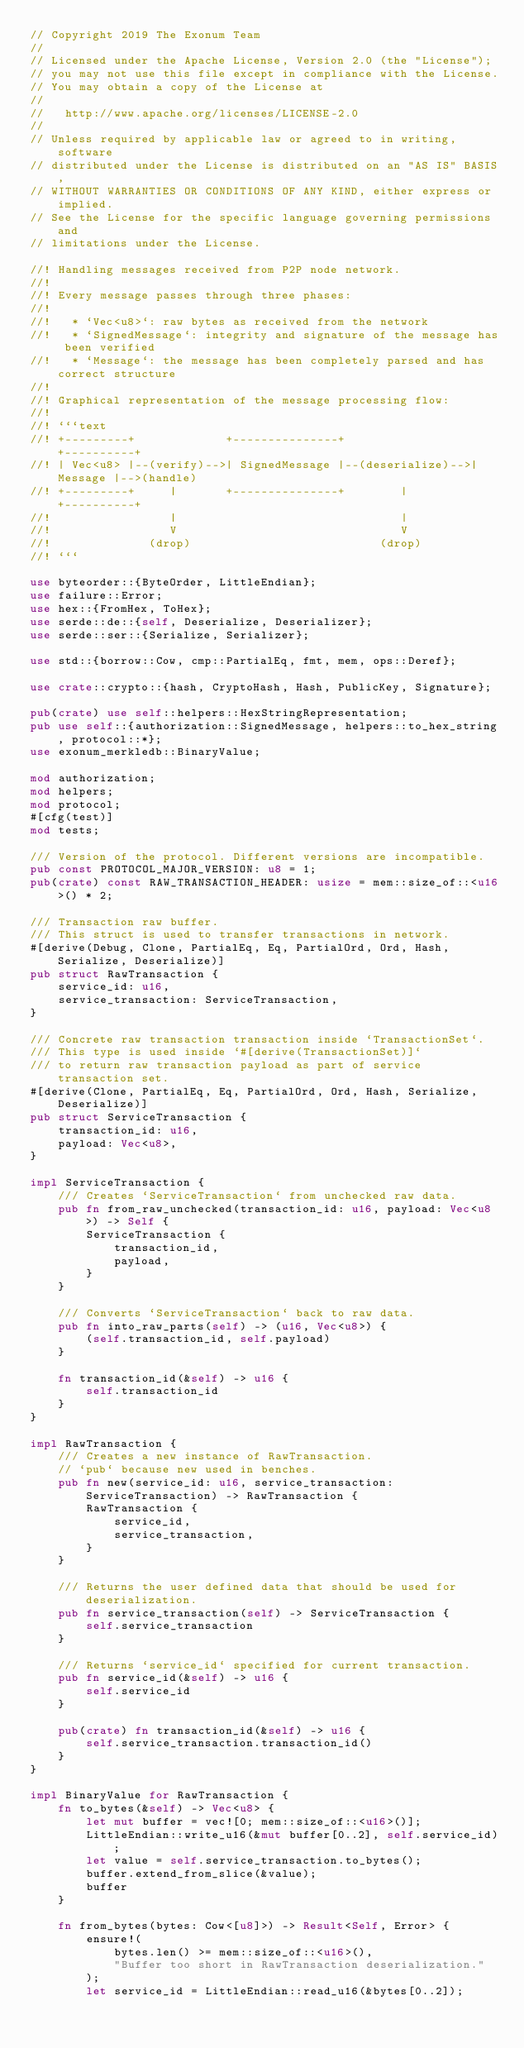Convert code to text. <code><loc_0><loc_0><loc_500><loc_500><_Rust_>// Copyright 2019 The Exonum Team
//
// Licensed under the Apache License, Version 2.0 (the "License");
// you may not use this file except in compliance with the License.
// You may obtain a copy of the License at
//
//   http://www.apache.org/licenses/LICENSE-2.0
//
// Unless required by applicable law or agreed to in writing, software
// distributed under the License is distributed on an "AS IS" BASIS,
// WITHOUT WARRANTIES OR CONDITIONS OF ANY KIND, either express or implied.
// See the License for the specific language governing permissions and
// limitations under the License.

//! Handling messages received from P2P node network.
//!
//! Every message passes through three phases:
//!
//!   * `Vec<u8>`: raw bytes as received from the network
//!   * `SignedMessage`: integrity and signature of the message has been verified
//!   * `Message`: the message has been completely parsed and has correct structure
//!
//! Graphical representation of the message processing flow:
//!
//! ```text
//! +---------+             +---------------+                  +----------+
//! | Vec<u8> |--(verify)-->| SignedMessage |--(deserialize)-->| Message |-->(handle)
//! +---------+     |       +---------------+        |         +----------+
//!                 |                                |
//!                 V                                V
//!              (drop)                           (drop)
//! ```

use byteorder::{ByteOrder, LittleEndian};
use failure::Error;
use hex::{FromHex, ToHex};
use serde::de::{self, Deserialize, Deserializer};
use serde::ser::{Serialize, Serializer};

use std::{borrow::Cow, cmp::PartialEq, fmt, mem, ops::Deref};

use crate::crypto::{hash, CryptoHash, Hash, PublicKey, Signature};

pub(crate) use self::helpers::HexStringRepresentation;
pub use self::{authorization::SignedMessage, helpers::to_hex_string, protocol::*};
use exonum_merkledb::BinaryValue;

mod authorization;
mod helpers;
mod protocol;
#[cfg(test)]
mod tests;

/// Version of the protocol. Different versions are incompatible.
pub const PROTOCOL_MAJOR_VERSION: u8 = 1;
pub(crate) const RAW_TRANSACTION_HEADER: usize = mem::size_of::<u16>() * 2;

/// Transaction raw buffer.
/// This struct is used to transfer transactions in network.
#[derive(Debug, Clone, PartialEq, Eq, PartialOrd, Ord, Hash, Serialize, Deserialize)]
pub struct RawTransaction {
    service_id: u16,
    service_transaction: ServiceTransaction,
}

/// Concrete raw transaction transaction inside `TransactionSet`.
/// This type is used inside `#[derive(TransactionSet)]`
/// to return raw transaction payload as part of service transaction set.
#[derive(Clone, PartialEq, Eq, PartialOrd, Ord, Hash, Serialize, Deserialize)]
pub struct ServiceTransaction {
    transaction_id: u16,
    payload: Vec<u8>,
}

impl ServiceTransaction {
    /// Creates `ServiceTransaction` from unchecked raw data.
    pub fn from_raw_unchecked(transaction_id: u16, payload: Vec<u8>) -> Self {
        ServiceTransaction {
            transaction_id,
            payload,
        }
    }

    /// Converts `ServiceTransaction` back to raw data.
    pub fn into_raw_parts(self) -> (u16, Vec<u8>) {
        (self.transaction_id, self.payload)
    }

    fn transaction_id(&self) -> u16 {
        self.transaction_id
    }
}

impl RawTransaction {
    /// Creates a new instance of RawTransaction.
    // `pub` because new used in benches.
    pub fn new(service_id: u16, service_transaction: ServiceTransaction) -> RawTransaction {
        RawTransaction {
            service_id,
            service_transaction,
        }
    }

    /// Returns the user defined data that should be used for deserialization.
    pub fn service_transaction(self) -> ServiceTransaction {
        self.service_transaction
    }

    /// Returns `service_id` specified for current transaction.
    pub fn service_id(&self) -> u16 {
        self.service_id
    }

    pub(crate) fn transaction_id(&self) -> u16 {
        self.service_transaction.transaction_id()
    }
}

impl BinaryValue for RawTransaction {
    fn to_bytes(&self) -> Vec<u8> {
        let mut buffer = vec![0; mem::size_of::<u16>()];
        LittleEndian::write_u16(&mut buffer[0..2], self.service_id);
        let value = self.service_transaction.to_bytes();
        buffer.extend_from_slice(&value);
        buffer
    }

    fn from_bytes(bytes: Cow<[u8]>) -> Result<Self, Error> {
        ensure!(
            bytes.len() >= mem::size_of::<u16>(),
            "Buffer too short in RawTransaction deserialization."
        );
        let service_id = LittleEndian::read_u16(&bytes[0..2]);</code> 